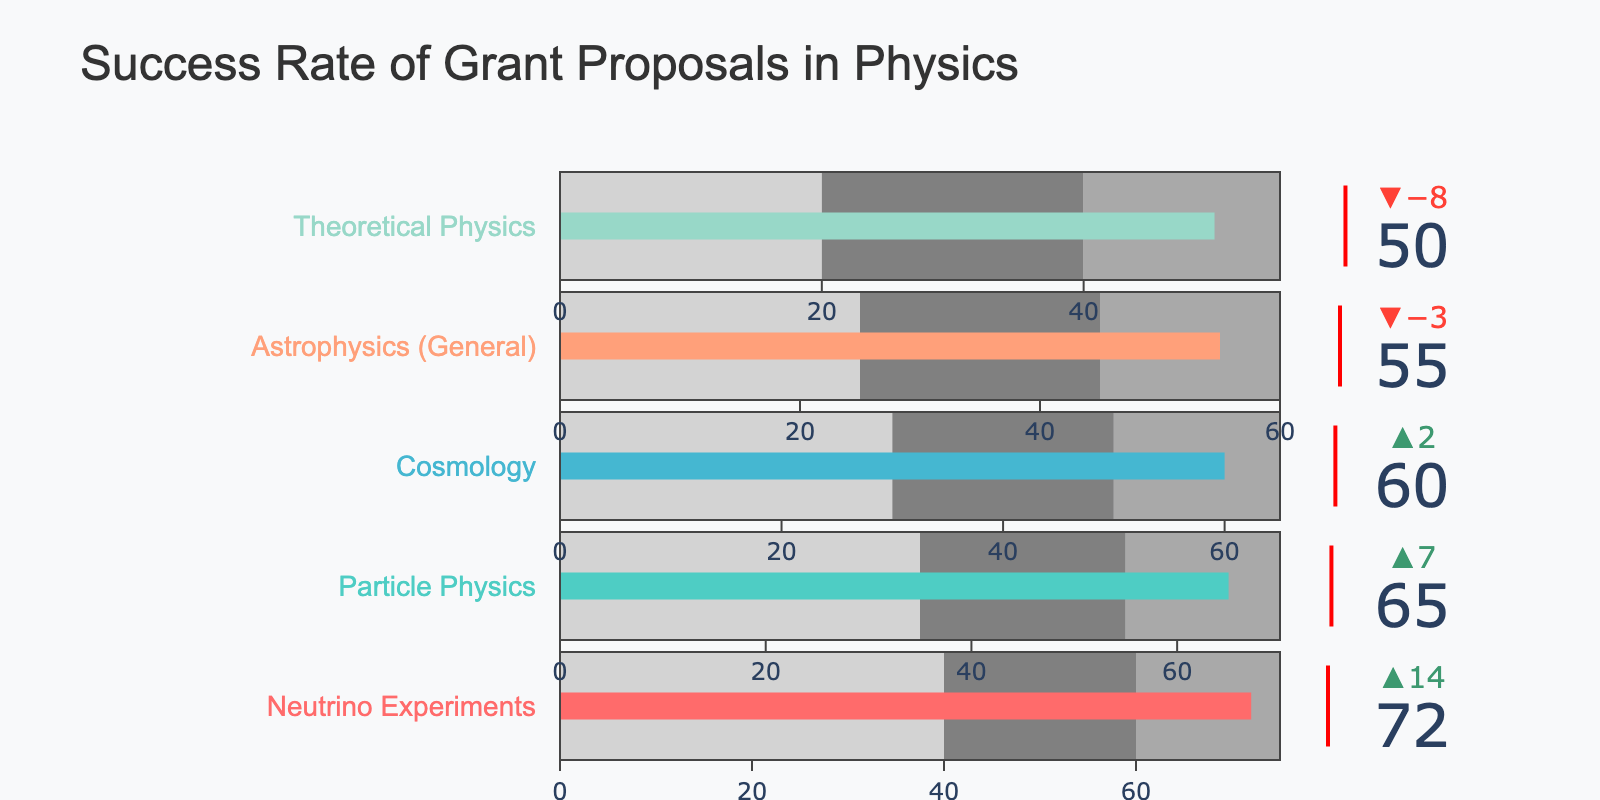what is the title of the figure? The title of the figure is typically shown at the top and provides an overview of the chart's subject. In this case, the title reads "Success Rate of Grant Proposals in Physics."
Answer: Success Rate of Grant Proposals in Physics How many categories are displayed in the figure? To determine the number of categories, count the distinct data points listed on the vertical axis. There are five rows indicating five categories: Neutrino Experiments, Particle Physics, Cosmology, Astrophysics (General), and Theoretical Physics.
Answer: Five Which category has the highest actual success rate? To identify the highest actual success rate, compare the "Actual" values across all categories. Neutrino Experiments has the highest actual success rate of 72%.
Answer: Neutrino Experiments Which category exceeds its target success rate? Compare the "Actual" and "Target" values for each category. Neutrino Experiments (72 vs 80), Particle Physics (65 vs 75), Cosmology (60 vs 70), Astrophysics (55 vs 65), and Theoretical Physics (50 vs 60) all fall short of their targets. None exceed their target.
Answer: None What's the difference between the actual and comparative success rates in the "Cosmology" category? Subtract the "Comparative" value from the "Actual" value for the Cosmology category. (60 - 58)
Answer: 2 What is the lowest target success rate among the categories? Find and compare the "Target" values across all categories. Theoretical Physics has the lowest target success rate of 60%.
Answer: 60% Which category has the smallest difference between its actual success rate and the comparative rate? Calculate the differences between the "Actual" and "Comparative" values for all categories:
Neutrino Experiments: 72 - 58 = 14
Particle Physics: 65 - 58 = 7
Cosmology: 60 - 58 = 2
Astrophysics: 55 - 58 = -3
Theoretical Physics: 50 - 58 = -8
The smallest difference is for Cosmology.
Answer: Cosmology How many categories have their actual success rates below the comparative success rate of 58%? Compare the actual success rates of each category to 58%. If the actual success rate is below 58%, count it. Only Astrophysics (General) and Theoretical Physics, with actual success rates of 55% and 50% respectively, fall below 58%.
Answer: Two What success rate range is used for light gray bars in the "Neutrino Experiments" category? In the bullet chart, the light gray section of the bar visualizes the lowest success range step. For Neutrino Experiments, the light gray bar covers the range from 0 to 40%.
Answer: 0 to 40% 